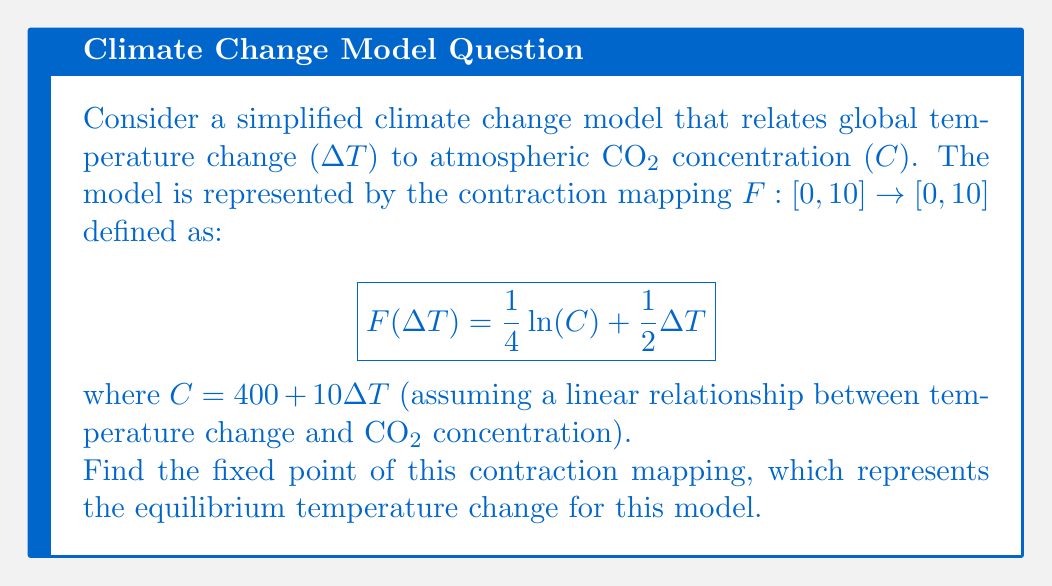Teach me how to tackle this problem. To find the fixed point of the contraction mapping, we need to solve the equation $F(\Delta T) = \Delta T$. Let's approach this step-by-step:

1) Set up the equation:
   $$\Delta T = \frac{1}{4} \ln(400 + 10\Delta T) + \frac{1}{2}\Delta T$$

2) Subtract $\frac{1}{2}\Delta T$ from both sides:
   $$\frac{1}{2}\Delta T = \frac{1}{4} \ln(400 + 10\Delta T)$$

3) Multiply both sides by 4:
   $$2\Delta T = \ln(400 + 10\Delta T)$$

4) Apply $e^x$ to both sides:
   $$e^{2\Delta T} = 400 + 10\Delta T$$

5) Rearrange the equation:
   $$e^{2\Delta T} - 10\Delta T - 400 = 0$$

6) This equation cannot be solved analytically. We need to use a numerical method, such as Newton's method, to find the solution.

7) Using Newton's method with an initial guess of $\Delta T_0 = 1$:

   $$\Delta T_{n+1} = \Delta T_n - \frac{f(\Delta T_n)}{f'(\Delta T_n)}$$

   where $f(\Delta T) = e^{2\Delta T} - 10\Delta T - 400$ and $f'(\Delta T) = 2e^{2\Delta T} - 10$

8) After several iterations, the solution converges to approximately $\Delta T \approx 2.0574$.

9) We can verify this is indeed a fixed point by plugging it back into the original function:

   $$F(2.0574) \approx \frac{1}{4} \ln(400 + 10(2.0574)) + \frac{1}{2}(2.0574) \approx 2.0574$$

Thus, the fixed point of the contraction mapping is approximately 2.0574.
Answer: The fixed point of the contraction mapping is approximately $\Delta T \approx 2.0574$°C. 